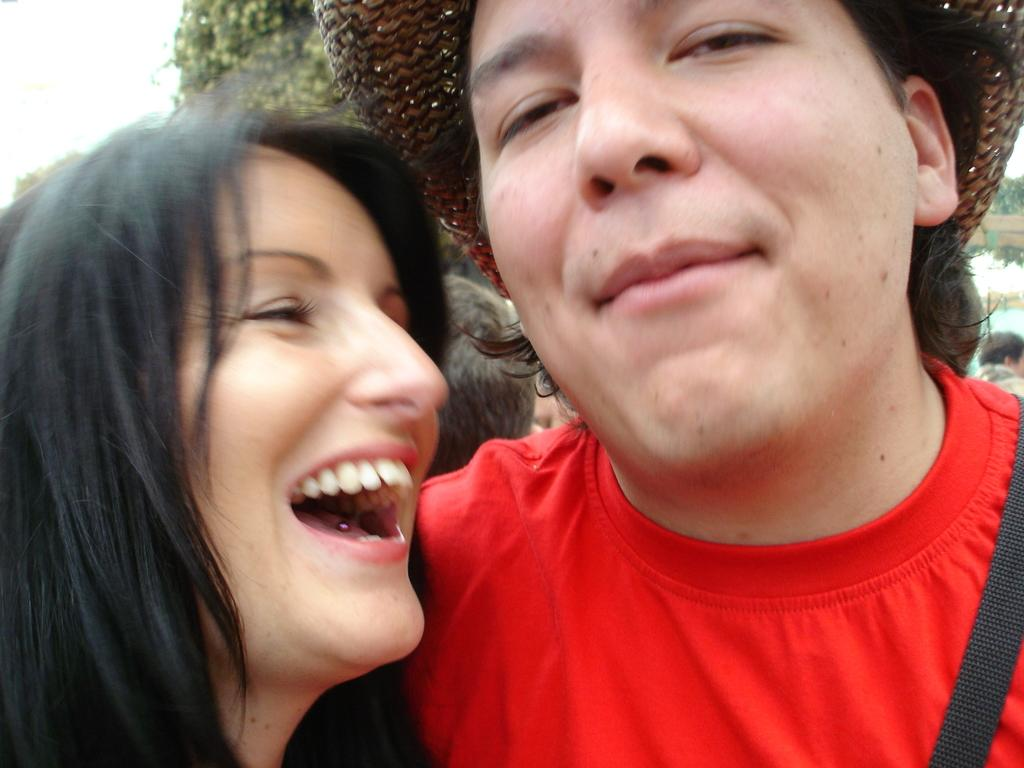How many people are in the image? There are two people in the image, a woman and a man. What is the man wearing on his upper body? The man is wearing a red t-shirt. What type of headwear is the man wearing? The man is wearing a hat. How does the woman appear in the image? The woman has a smile on her face. What type of string is the man using to cut the blade in the image? There is no string or blade present in the image; it features a woman and a man. 